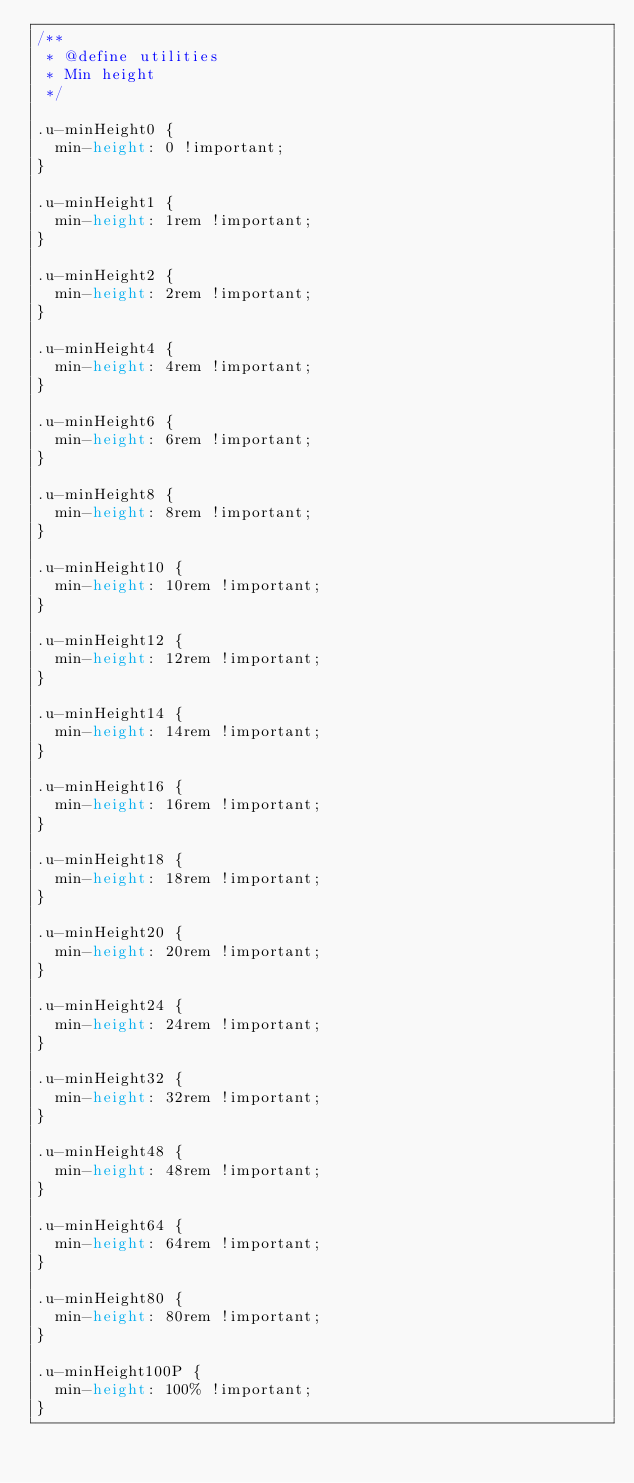Convert code to text. <code><loc_0><loc_0><loc_500><loc_500><_CSS_>/**
 * @define utilities
 * Min height
 */

.u-minHeight0 {
  min-height: 0 !important;
}

.u-minHeight1 {
  min-height: 1rem !important;
}

.u-minHeight2 {
  min-height: 2rem !important;
}

.u-minHeight4 {
  min-height: 4rem !important;
}

.u-minHeight6 {
  min-height: 6rem !important;
}

.u-minHeight8 {
  min-height: 8rem !important;
}

.u-minHeight10 {
  min-height: 10rem !important;
}

.u-minHeight12 {
  min-height: 12rem !important;
}

.u-minHeight14 {
  min-height: 14rem !important;
}

.u-minHeight16 {
  min-height: 16rem !important;
}

.u-minHeight18 {
  min-height: 18rem !important;
}

.u-minHeight20 {
  min-height: 20rem !important;
}

.u-minHeight24 {
  min-height: 24rem !important;
}

.u-minHeight32 {
  min-height: 32rem !important;
}

.u-minHeight48 {
  min-height: 48rem !important;
}

.u-minHeight64 {
  min-height: 64rem !important;
}

.u-minHeight80 {
  min-height: 80rem !important;
}

.u-minHeight100P {
  min-height: 100% !important;
}
</code> 